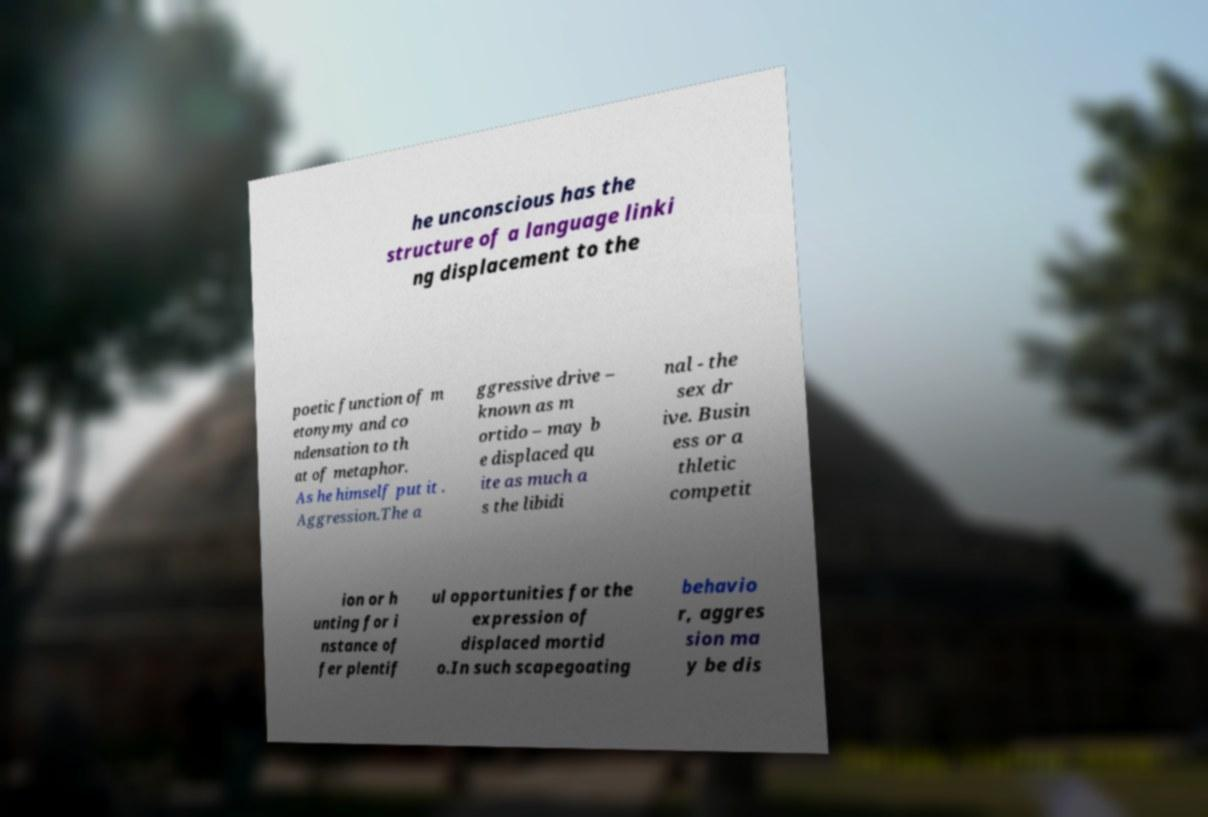I need the written content from this picture converted into text. Can you do that? he unconscious has the structure of a language linki ng displacement to the poetic function of m etonymy and co ndensation to th at of metaphor. As he himself put it . Aggression.The a ggressive drive – known as m ortido – may b e displaced qu ite as much a s the libidi nal - the sex dr ive. Busin ess or a thletic competit ion or h unting for i nstance of fer plentif ul opportunities for the expression of displaced mortid o.In such scapegoating behavio r, aggres sion ma y be dis 